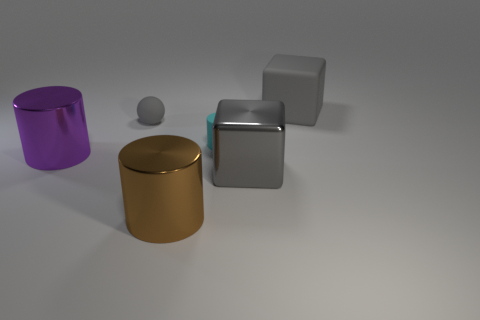Add 2 purple shiny cylinders. How many objects exist? 8 Subtract all tiny cyan matte cylinders. How many cylinders are left? 2 Subtract all purple cylinders. How many cylinders are left? 2 Subtract all blocks. How many objects are left? 4 Add 1 cyan matte cylinders. How many cyan matte cylinders are left? 2 Add 4 large red metal things. How many large red metal things exist? 4 Subtract 0 purple spheres. How many objects are left? 6 Subtract all cyan blocks. Subtract all green cylinders. How many blocks are left? 2 Subtract all brown balls. Subtract all brown things. How many objects are left? 5 